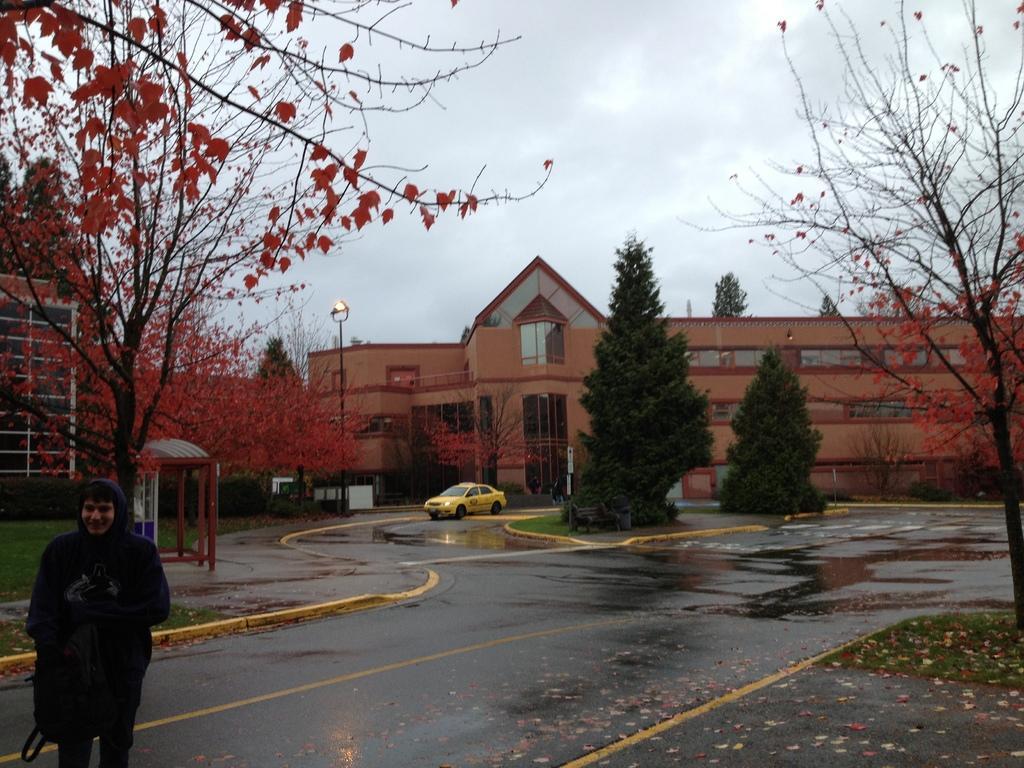Please provide a concise description of this image. In the center of the image we can see a car on the road. On the left there is a man standing. In the background there are trees, pole, buildings and sky. 